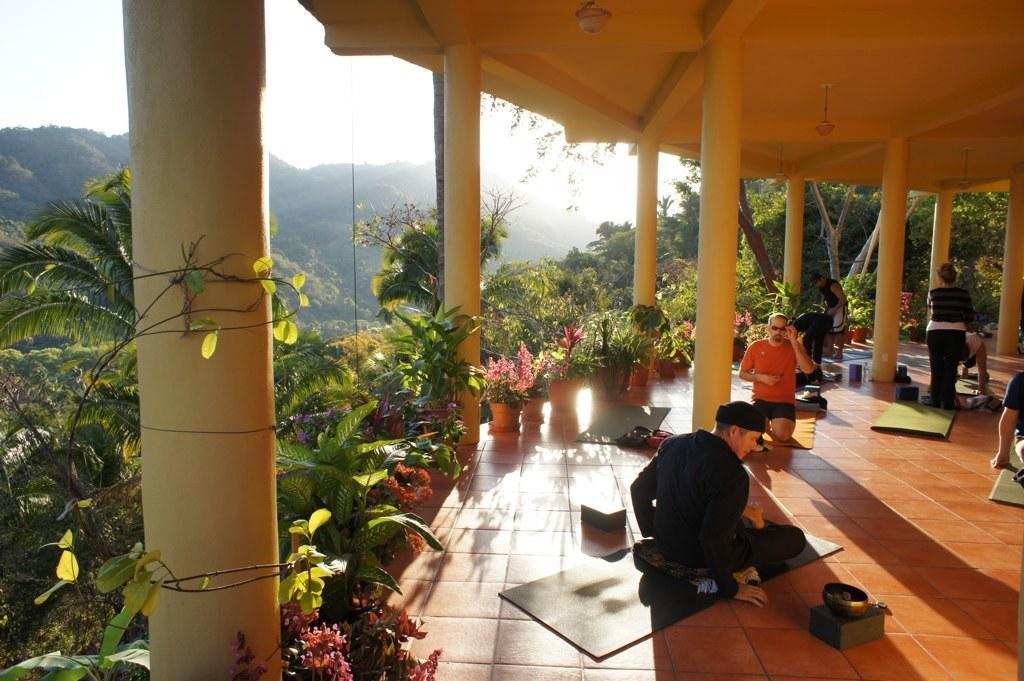Can you describe this image briefly? In this picture I can see group of people, there are mars and some other objects on the floor, there are lights, there is a shelter with pillars, there are plants, flowers, trees, there are hills, and in the background there is the sky. 